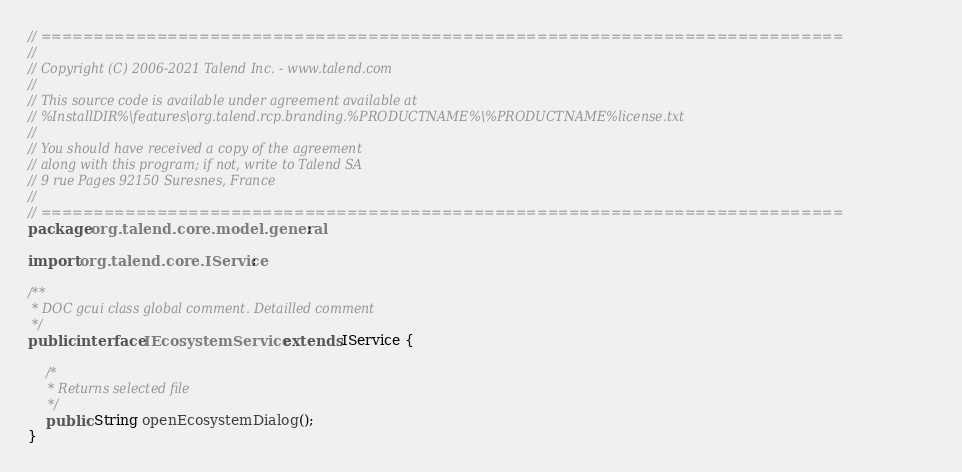Convert code to text. <code><loc_0><loc_0><loc_500><loc_500><_Java_>// ============================================================================
//
// Copyright (C) 2006-2021 Talend Inc. - www.talend.com
//
// This source code is available under agreement available at
// %InstallDIR%\features\org.talend.rcp.branding.%PRODUCTNAME%\%PRODUCTNAME%license.txt
//
// You should have received a copy of the agreement
// along with this program; if not, write to Talend SA
// 9 rue Pages 92150 Suresnes, France
//
// ============================================================================
package org.talend.core.model.general;

import org.talend.core.IService;

/**
 * DOC gcui class global comment. Detailled comment
 */
public interface IEcosystemService extends IService {

    /*
     * Returns selected file
     */
    public String openEcosystemDialog();
}
</code> 